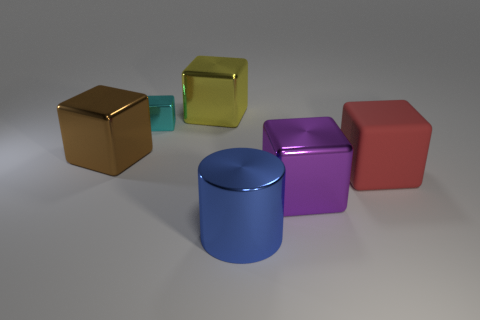Subtract all yellow metallic blocks. How many blocks are left? 4 Subtract all purple cubes. How many cubes are left? 4 Subtract all blue cubes. Subtract all gray spheres. How many cubes are left? 5 Add 2 large purple blocks. How many objects exist? 8 Subtract all blocks. How many objects are left? 1 Subtract 0 blue cubes. How many objects are left? 6 Subtract all big yellow cubes. Subtract all big red matte objects. How many objects are left? 4 Add 6 big yellow shiny cubes. How many big yellow shiny cubes are left? 7 Add 2 large gray metal cubes. How many large gray metal cubes exist? 2 